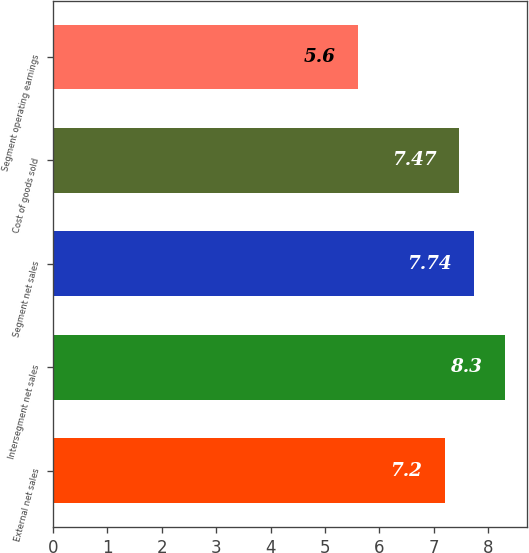Convert chart. <chart><loc_0><loc_0><loc_500><loc_500><bar_chart><fcel>External net sales<fcel>Intersegment net sales<fcel>Segment net sales<fcel>Cost of goods sold<fcel>Segment operating earnings<nl><fcel>7.2<fcel>8.3<fcel>7.74<fcel>7.47<fcel>5.6<nl></chart> 